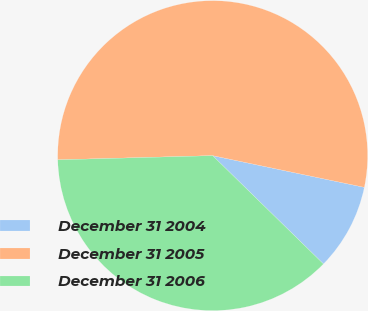Convert chart. <chart><loc_0><loc_0><loc_500><loc_500><pie_chart><fcel>December 31 2004<fcel>December 31 2005<fcel>December 31 2006<nl><fcel>9.04%<fcel>53.71%<fcel>37.25%<nl></chart> 